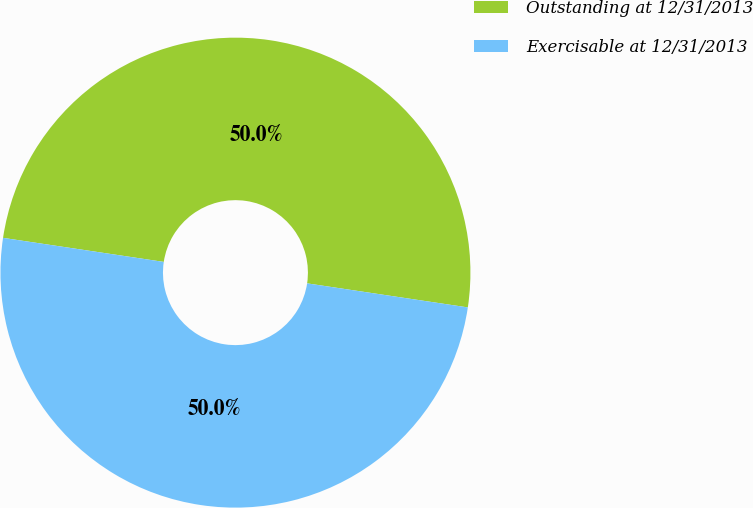Convert chart to OTSL. <chart><loc_0><loc_0><loc_500><loc_500><pie_chart><fcel>Outstanding at 12/31/2013<fcel>Exercisable at 12/31/2013<nl><fcel>50.0%<fcel>50.0%<nl></chart> 